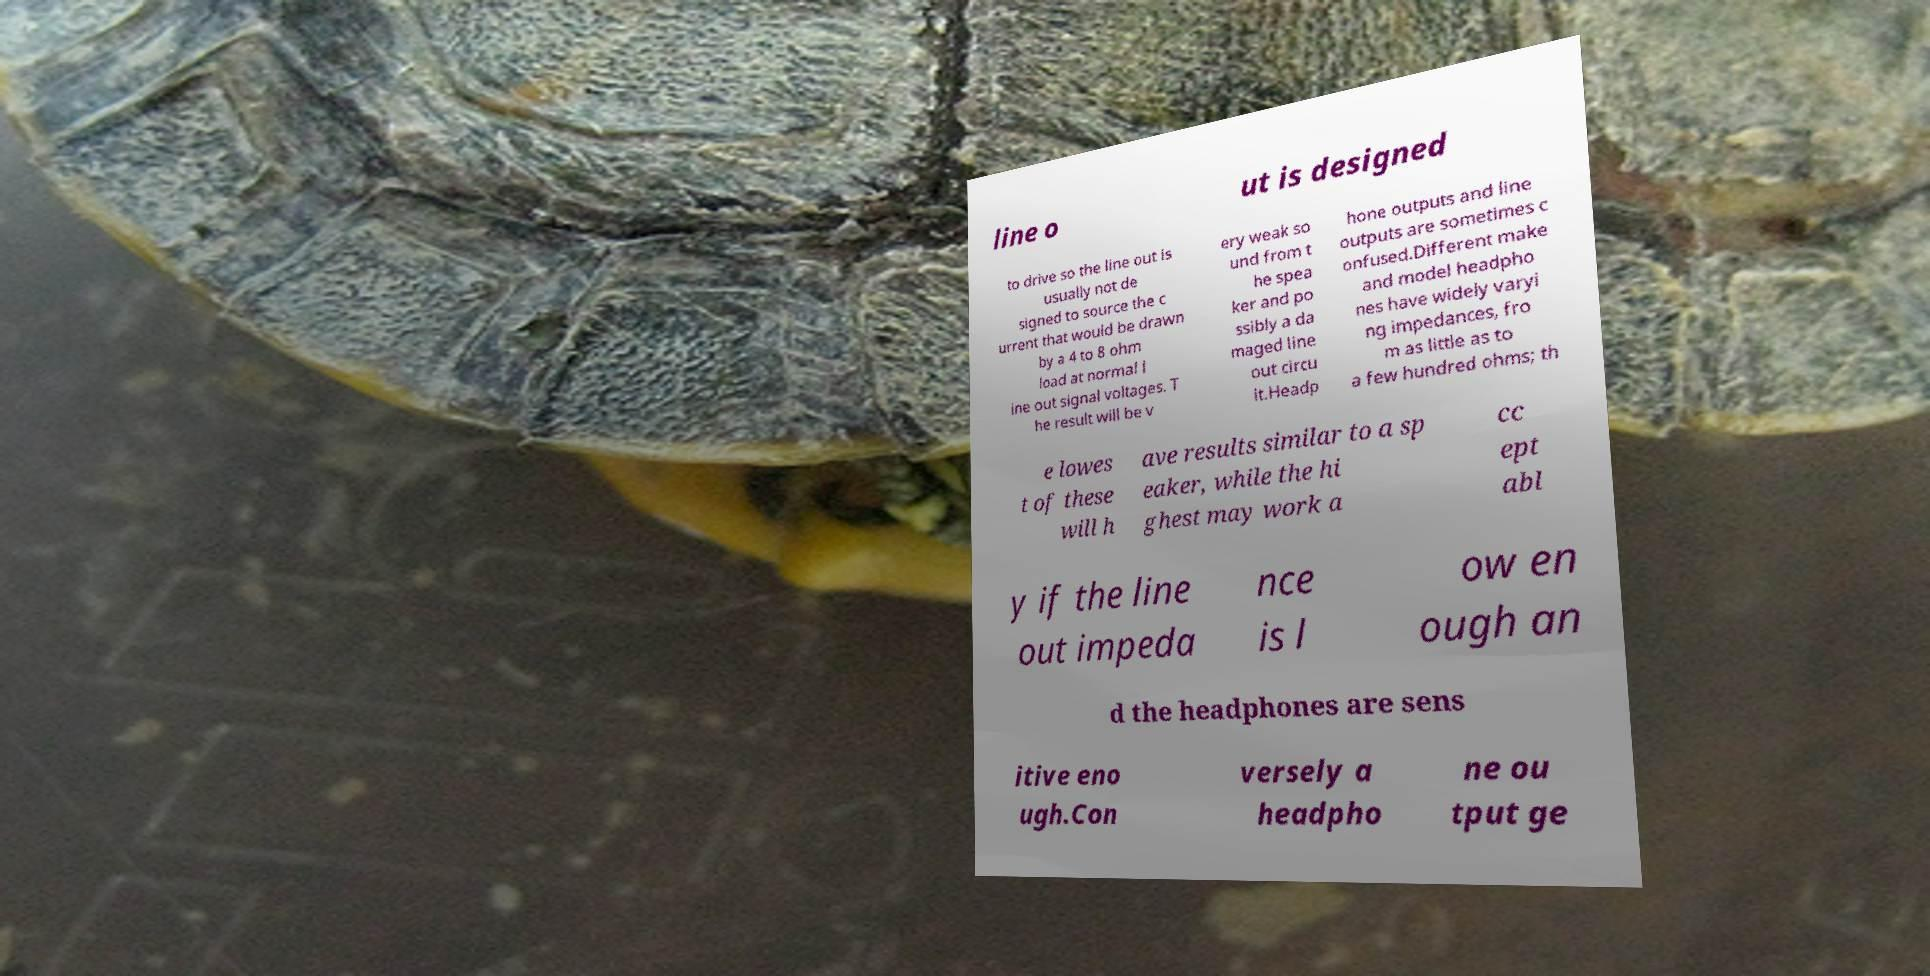Please read and relay the text visible in this image. What does it say? line o ut is designed to drive so the line out is usually not de signed to source the c urrent that would be drawn by a 4 to 8 ohm load at normal l ine out signal voltages. T he result will be v ery weak so und from t he spea ker and po ssibly a da maged line out circu it.Headp hone outputs and line outputs are sometimes c onfused.Different make and model headpho nes have widely varyi ng impedances, fro m as little as to a few hundred ohms; th e lowes t of these will h ave results similar to a sp eaker, while the hi ghest may work a cc ept abl y if the line out impeda nce is l ow en ough an d the headphones are sens itive eno ugh.Con versely a headpho ne ou tput ge 